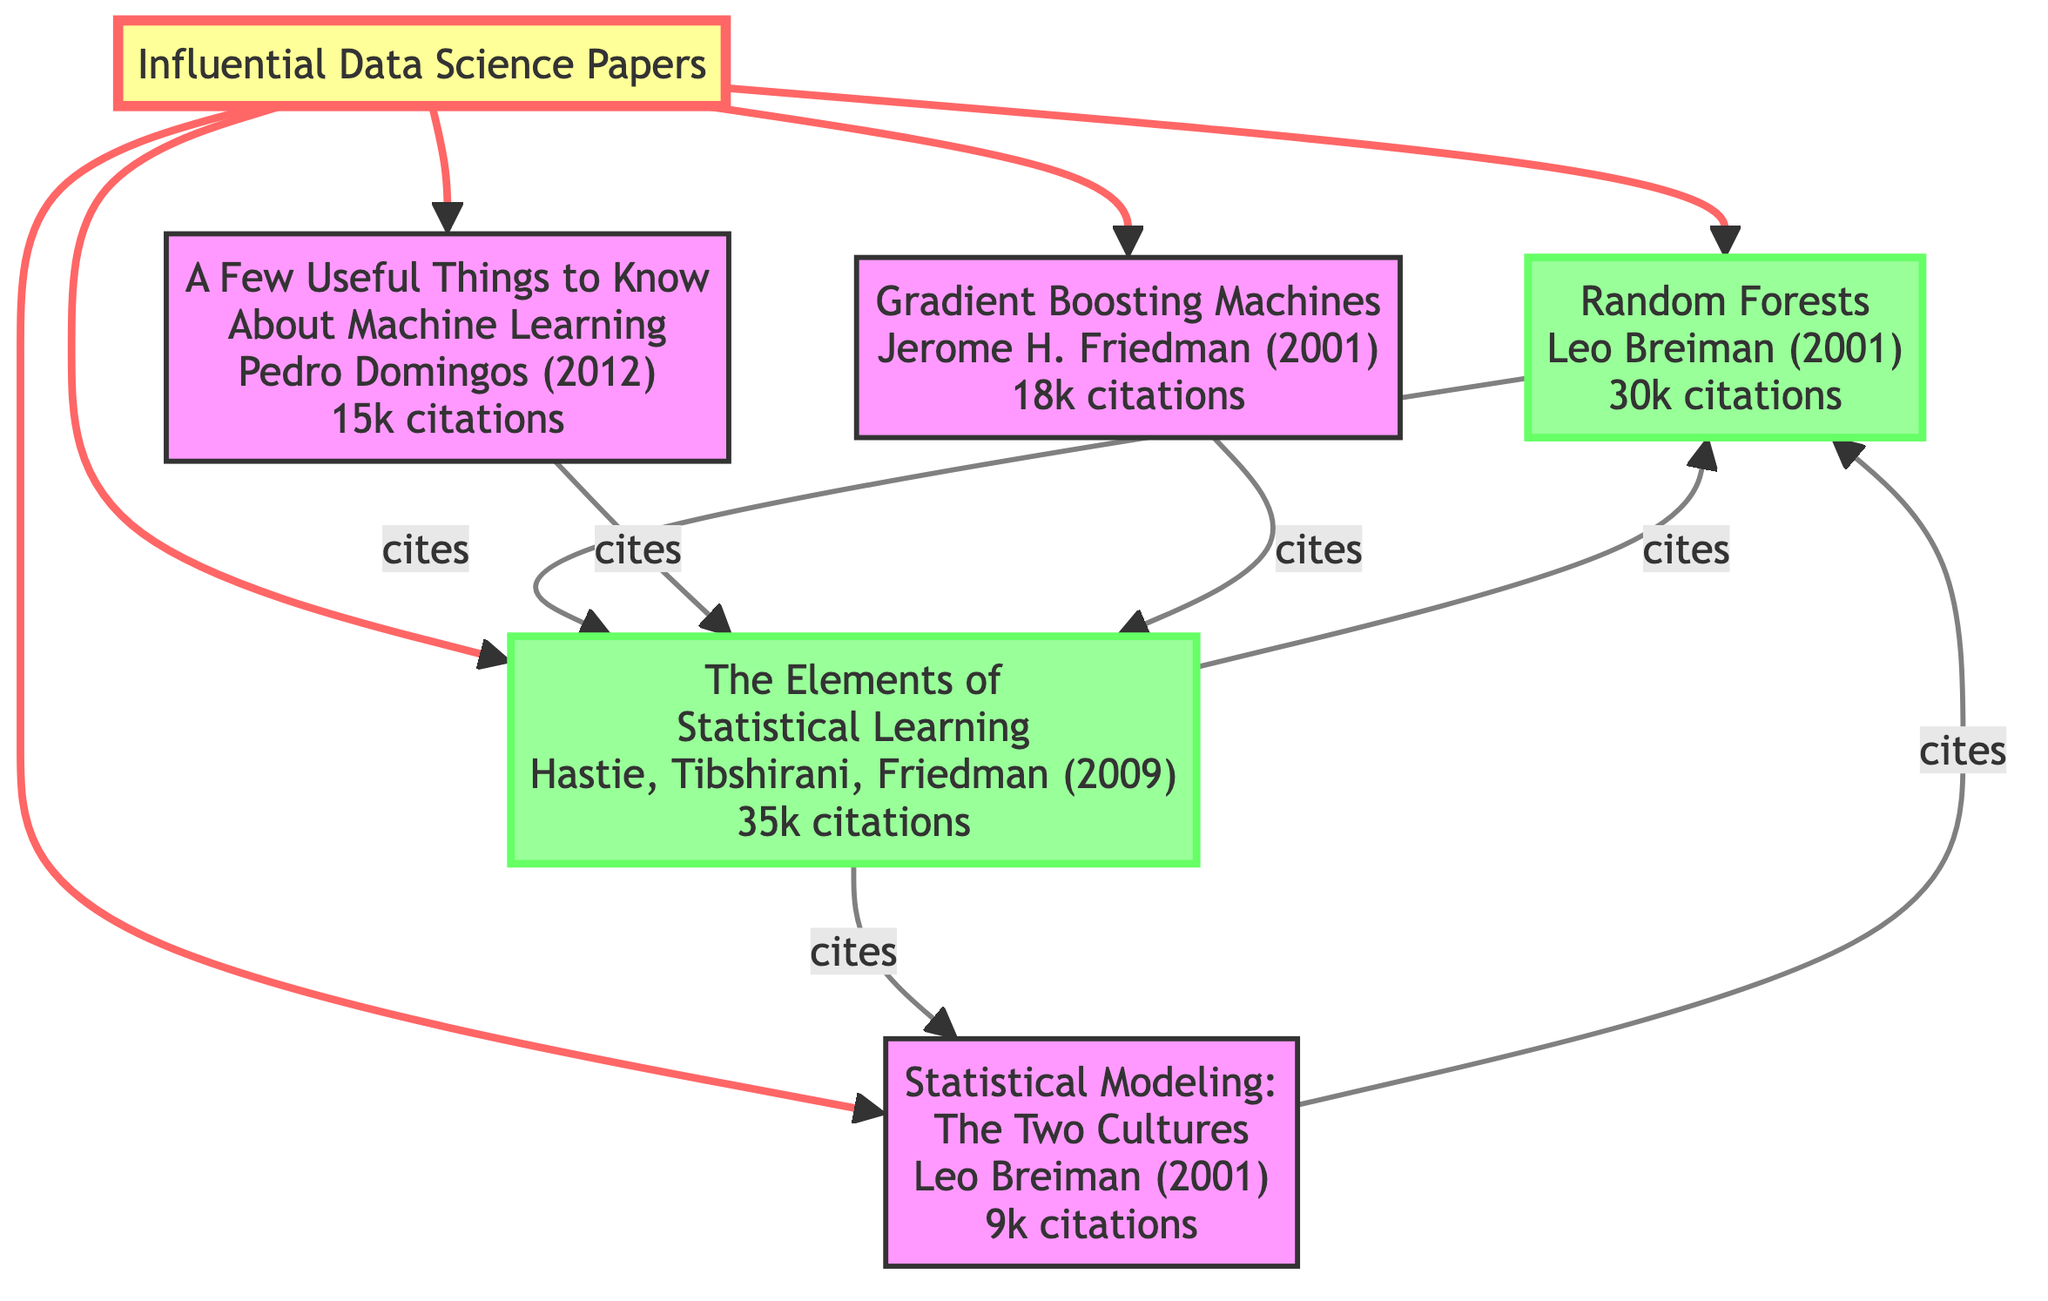What is the total number of influential papers in the diagram? The diagram includes five distinct papers: Random Forests, A Few Useful Things to Know About Machine Learning, Gradient Boosting Machines, The Elements of Statistical Learning, and Statistical Modeling: The Two Cultures.
Answer: 5 Which paper has the highest citation count? By reviewing the citation counts provided in the diagram's nodes, The Elements of Statistical Learning has 35,000 citations, which is the highest among all listed papers.
Answer: The Elements of Statistical Learning How many citations does the paper "Random Forests" have? The citation count for Random Forests is explicitly stated in the diagram as 30,000 citations.
Answer: 30000 Which papers cite "The Elements of Statistical Learning"? Analyzing the edges, Random Forests, A Few Useful Things to Know About Machine Learning, and Gradient Boosting Machines are all connected to "The Elements of Statistical Learning" as citing papers.
Answer: Random Forests, A Few Useful Things to Know About Machine Learning, Gradient Boosting Machines What is the relationship between "Statistical Modeling: The Two Cultures" and "Random Forests"? The edge indicates that Statistical Modeling: The Two Cultures cites Random Forests, establishing a direct relationship where Statistical Modeling references the research found in Random Forests.
Answer: cites Which author is associated with the paper "A Few Useful Things to Know About Machine Learning"? The diagram lists Pedro Domingos as the author of this paper.
Answer: Pedro Domingos How many total citations do the papers citing "The Elements of Statistical Learning" have? The papers citing "The Elements of Statistical Learning" are Random Forests (30,000), A Few Useful Things to Know About Machine Learning (15,000), and Gradient Boosting Machines (18,000). Adding these gives 30,000 + 15,000 + 18,000 = 63,000 total citations.
Answer: 63000 Which paper has a citation flow directed towards "Random Forests"? The edge labeled 'cites' shows that The Elements of Statistical Learning cites Random Forests, indicating a citation flow directed towards it.
Answer: The Elements of Statistical Learning 